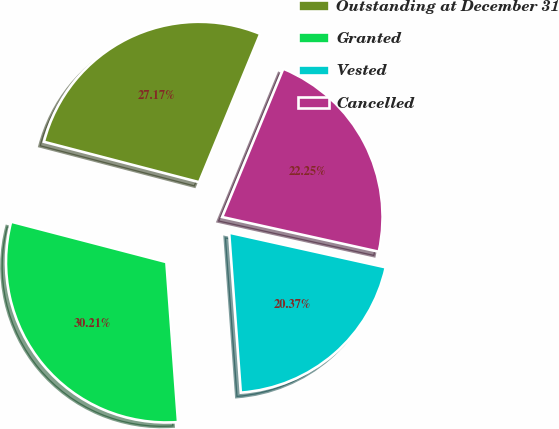Convert chart. <chart><loc_0><loc_0><loc_500><loc_500><pie_chart><fcel>Outstanding at December 31<fcel>Granted<fcel>Vested<fcel>Cancelled<nl><fcel>27.17%<fcel>30.21%<fcel>20.37%<fcel>22.25%<nl></chart> 